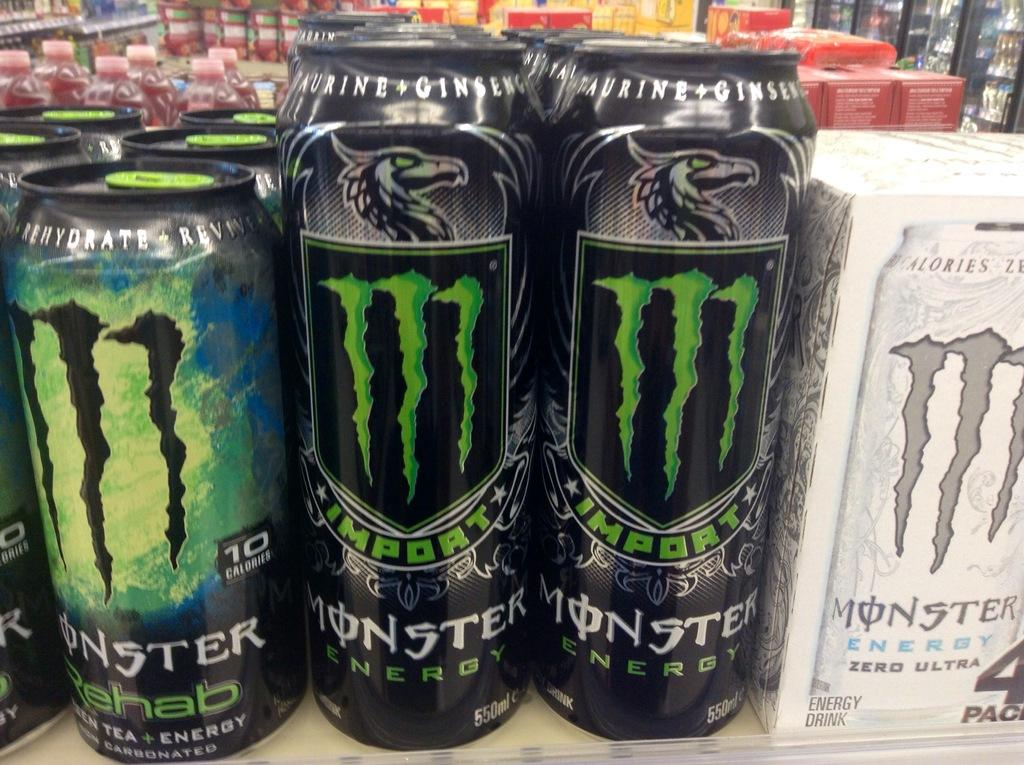Provide a one-sentence caption for the provided image. Some monster energy drinks with a green M on them. 